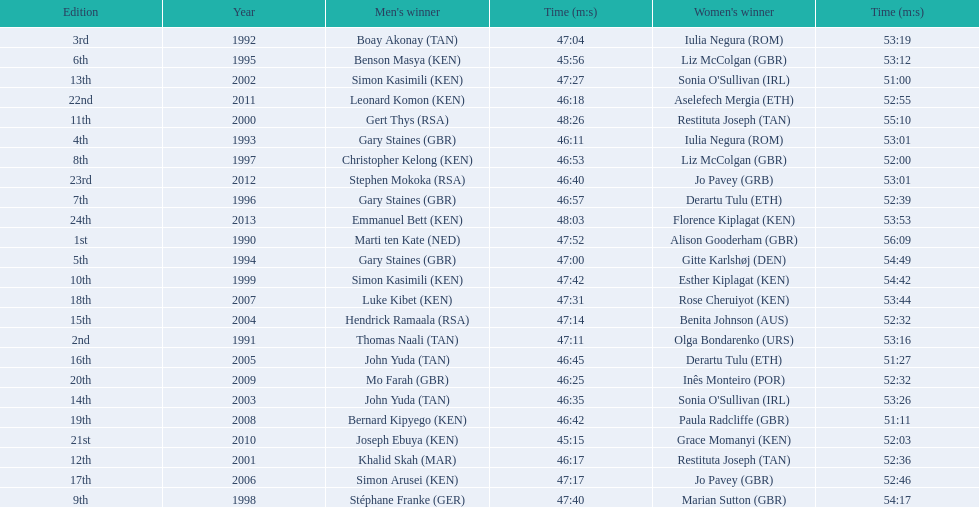What are the names of each male winner? Marti ten Kate (NED), Thomas Naali (TAN), Boay Akonay (TAN), Gary Staines (GBR), Gary Staines (GBR), Benson Masya (KEN), Gary Staines (GBR), Christopher Kelong (KEN), Stéphane Franke (GER), Simon Kasimili (KEN), Gert Thys (RSA), Khalid Skah (MAR), Simon Kasimili (KEN), John Yuda (TAN), Hendrick Ramaala (RSA), John Yuda (TAN), Simon Arusei (KEN), Luke Kibet (KEN), Bernard Kipyego (KEN), Mo Farah (GBR), Joseph Ebuya (KEN), Leonard Komon (KEN), Stephen Mokoka (RSA), Emmanuel Bett (KEN). When did they race? 1990, 1991, 1992, 1993, 1994, 1995, 1996, 1997, 1998, 1999, 2000, 2001, 2002, 2003, 2004, 2005, 2006, 2007, 2008, 2009, 2010, 2011, 2012, 2013. And what were their times? 47:52, 47:11, 47:04, 46:11, 47:00, 45:56, 46:57, 46:53, 47:40, 47:42, 48:26, 46:17, 47:27, 46:35, 47:14, 46:45, 47:17, 47:31, 46:42, 46:25, 45:15, 46:18, 46:40, 48:03. Of those times, which athlete had the fastest time? Joseph Ebuya (KEN). 